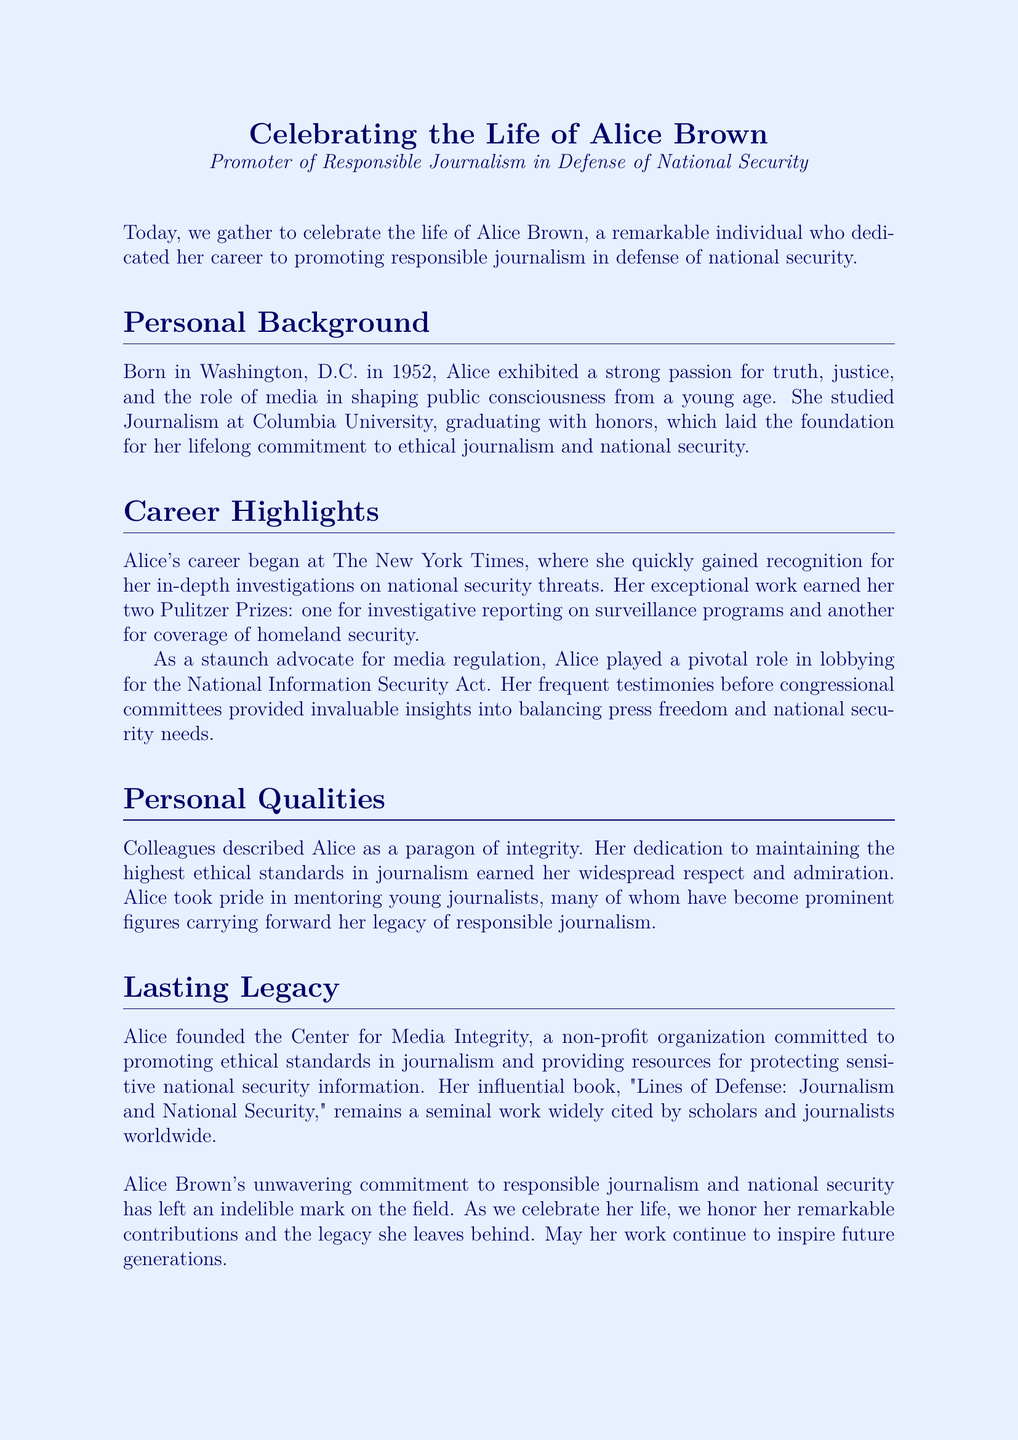What year was Alice Brown born? The document states she was born in Washington, D.C. in 1952.
Answer: 1952 What university did Alice Brown attend? It is mentioned that Alice studied Journalism at Columbia University.
Answer: Columbia University How many Pulitzer Prizes did Alice win? The document notes that Alice earned two Pulitzer Prizes during her career.
Answer: Two What is the name of Alice's influential book? The document mentions her book titled "Lines of Defense: Journalism and National Security."
Answer: Lines of Defense: Journalism and National Security What organization did Alice found? The document states that she founded the Center for Media Integrity.
Answer: Center for Media Integrity Why is Alice described as a paragon of integrity? The document highlights her dedication to maintaining the highest ethical standards in journalism.
Answer: Highest ethical standards What role did Alice play in the National Information Security Act? She played a pivotal role in lobbying for the National Information Security Act.
Answer: Lobbying What was one of Alice's early career highlights? The document states she gained recognition for her in-depth investigations on national security threats at The New York Times.
Answer: Investigations on national security threats What was Alice's lifelong commitment? The document mentions her commitment to ethical journalism and national security.
Answer: Ethical journalism and national security 